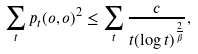Convert formula to latex. <formula><loc_0><loc_0><loc_500><loc_500>\sum _ { t } p _ { t } ( o , o ) ^ { 2 } \leq \sum _ { t } \frac { c } { t ( \log { t } ) ^ { \frac { 2 } { \beta } } } ,</formula> 